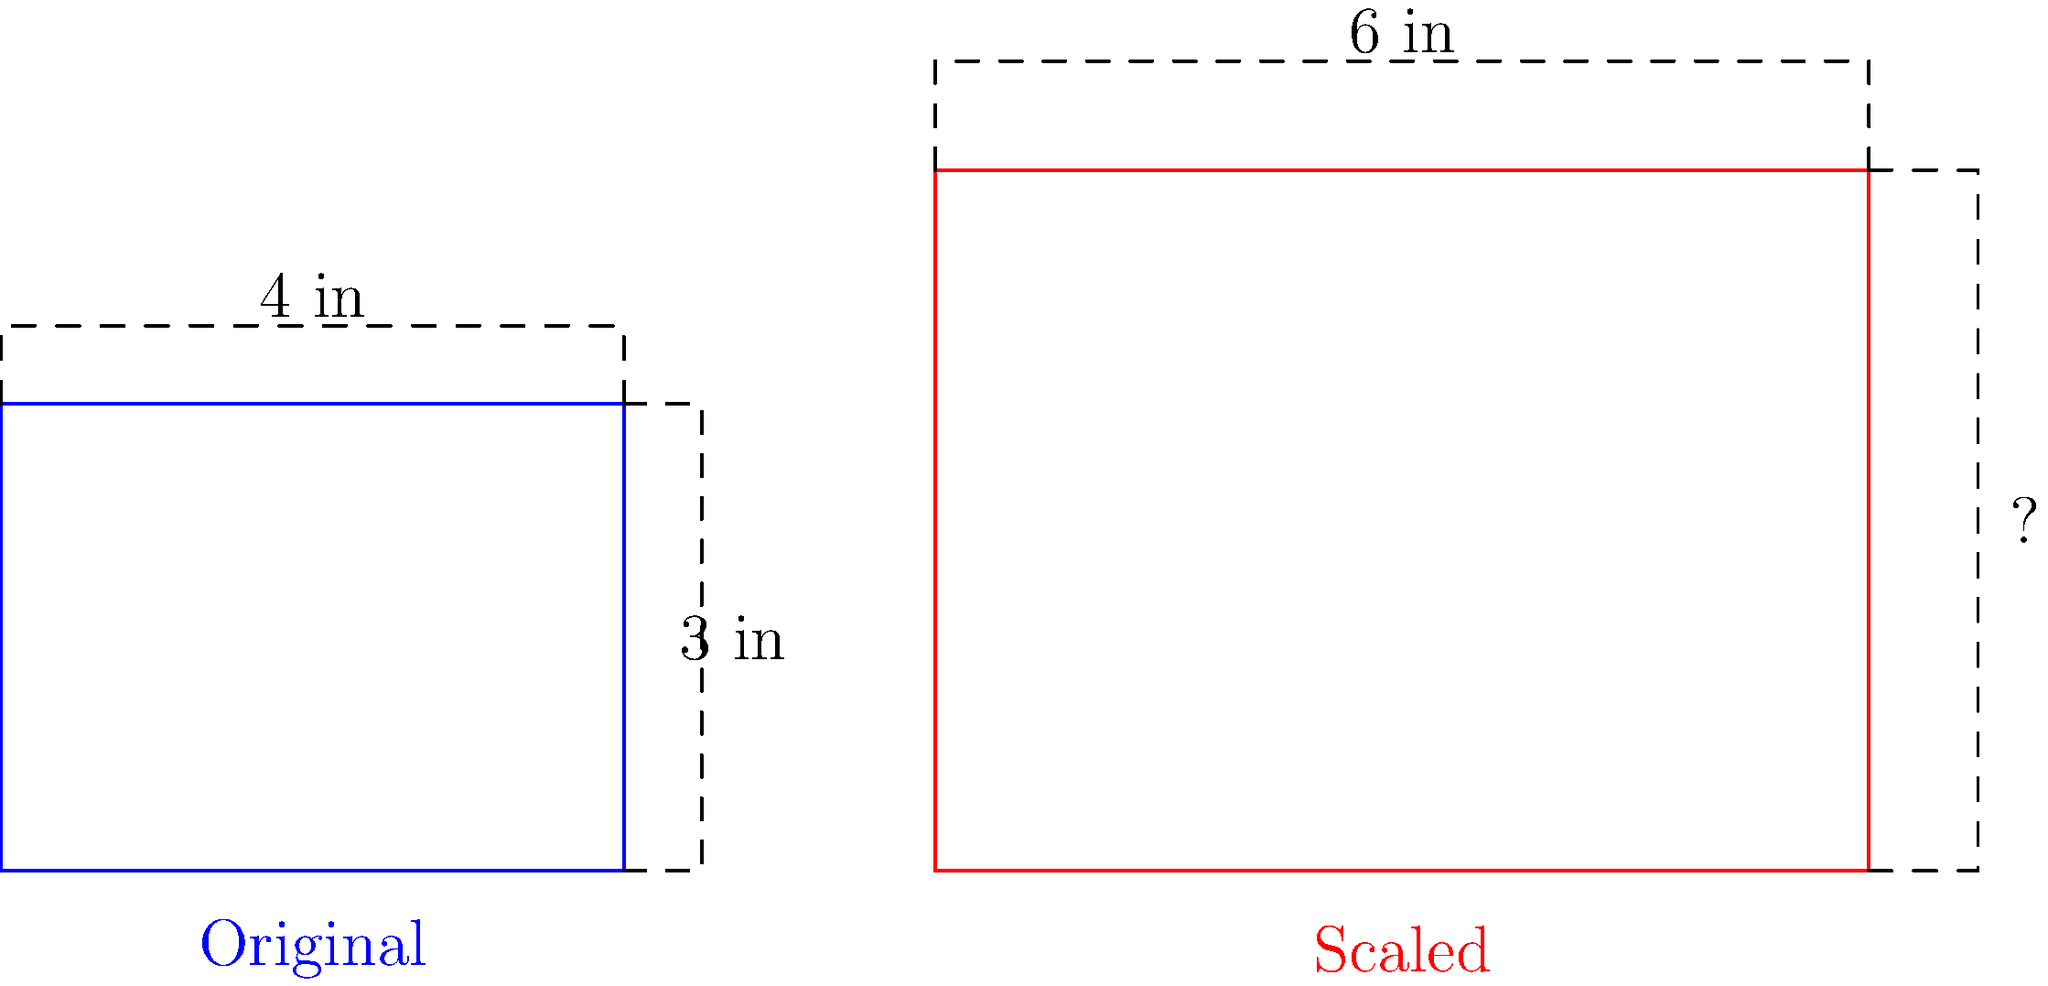In a print advertisement layout, you need to scale up an image while maintaining its aspect ratio. The original image is 4 inches wide and 3 inches tall. If you increase the width to 6 inches, what will be the new height of the image? To solve this problem, we need to use the concept of proportions and scaling. Here's a step-by-step approach:

1. Identify the original dimensions:
   Width = 4 inches
   Height = 3 inches

2. Identify the new width:
   New width = 6 inches

3. Calculate the scale factor:
   Scale factor = New width / Original width
   $$ \text{Scale factor} = \frac{6 \text{ inches}}{4 \text{ inches}} = 1.5 $$

4. Apply the scale factor to the height:
   New height = Original height × Scale factor
   $$ \text{New height} = 3 \text{ inches} \times 1.5 = 4.5 \text{ inches} $$

5. Verify that the aspect ratio is maintained:
   Original aspect ratio = 4:3
   New aspect ratio = 6:4.5 = 4:3 (simplified)

Therefore, the new height of the scaled image will be 4.5 inches.
Answer: 4.5 inches 